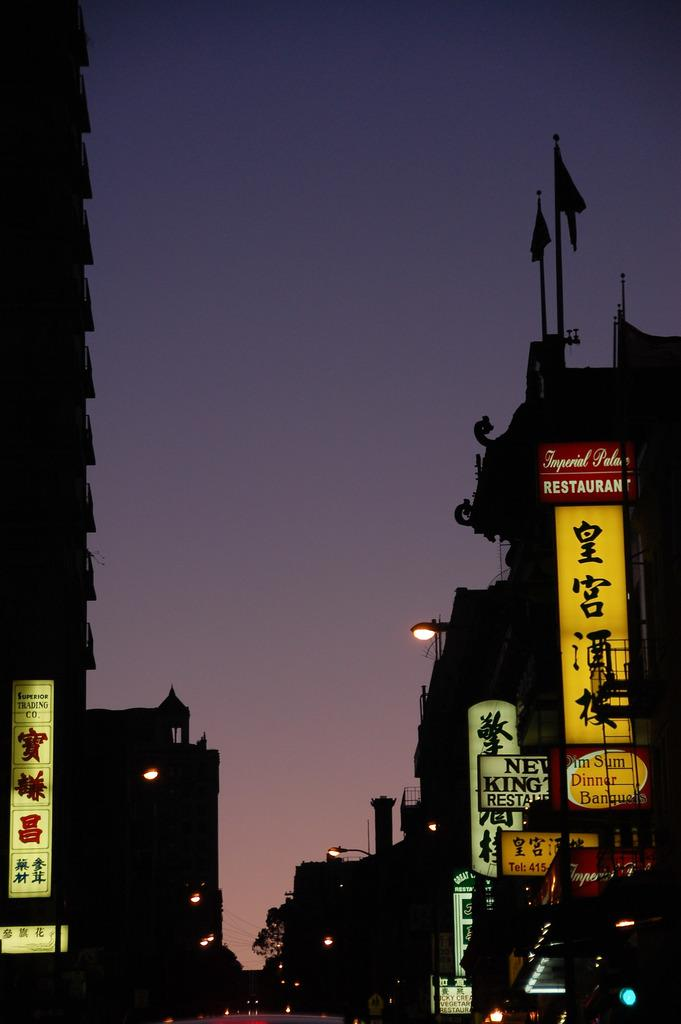<image>
Offer a succinct explanation of the picture presented. The yellow sign to the advertises a restaurant in white and red above. 